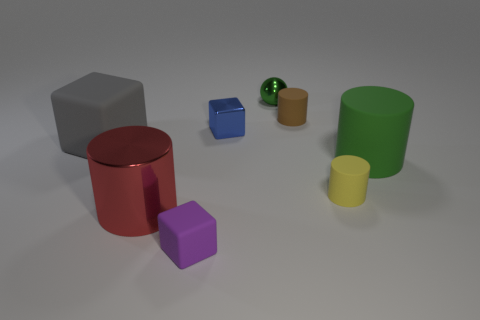Subtract 1 cylinders. How many cylinders are left? 3 Add 2 green matte cylinders. How many objects exist? 10 Subtract all cubes. How many objects are left? 5 Add 6 red matte objects. How many red matte objects exist? 6 Subtract 0 brown spheres. How many objects are left? 8 Subtract all large green cylinders. Subtract all small blue shiny blocks. How many objects are left? 6 Add 8 big gray matte objects. How many big gray matte objects are left? 9 